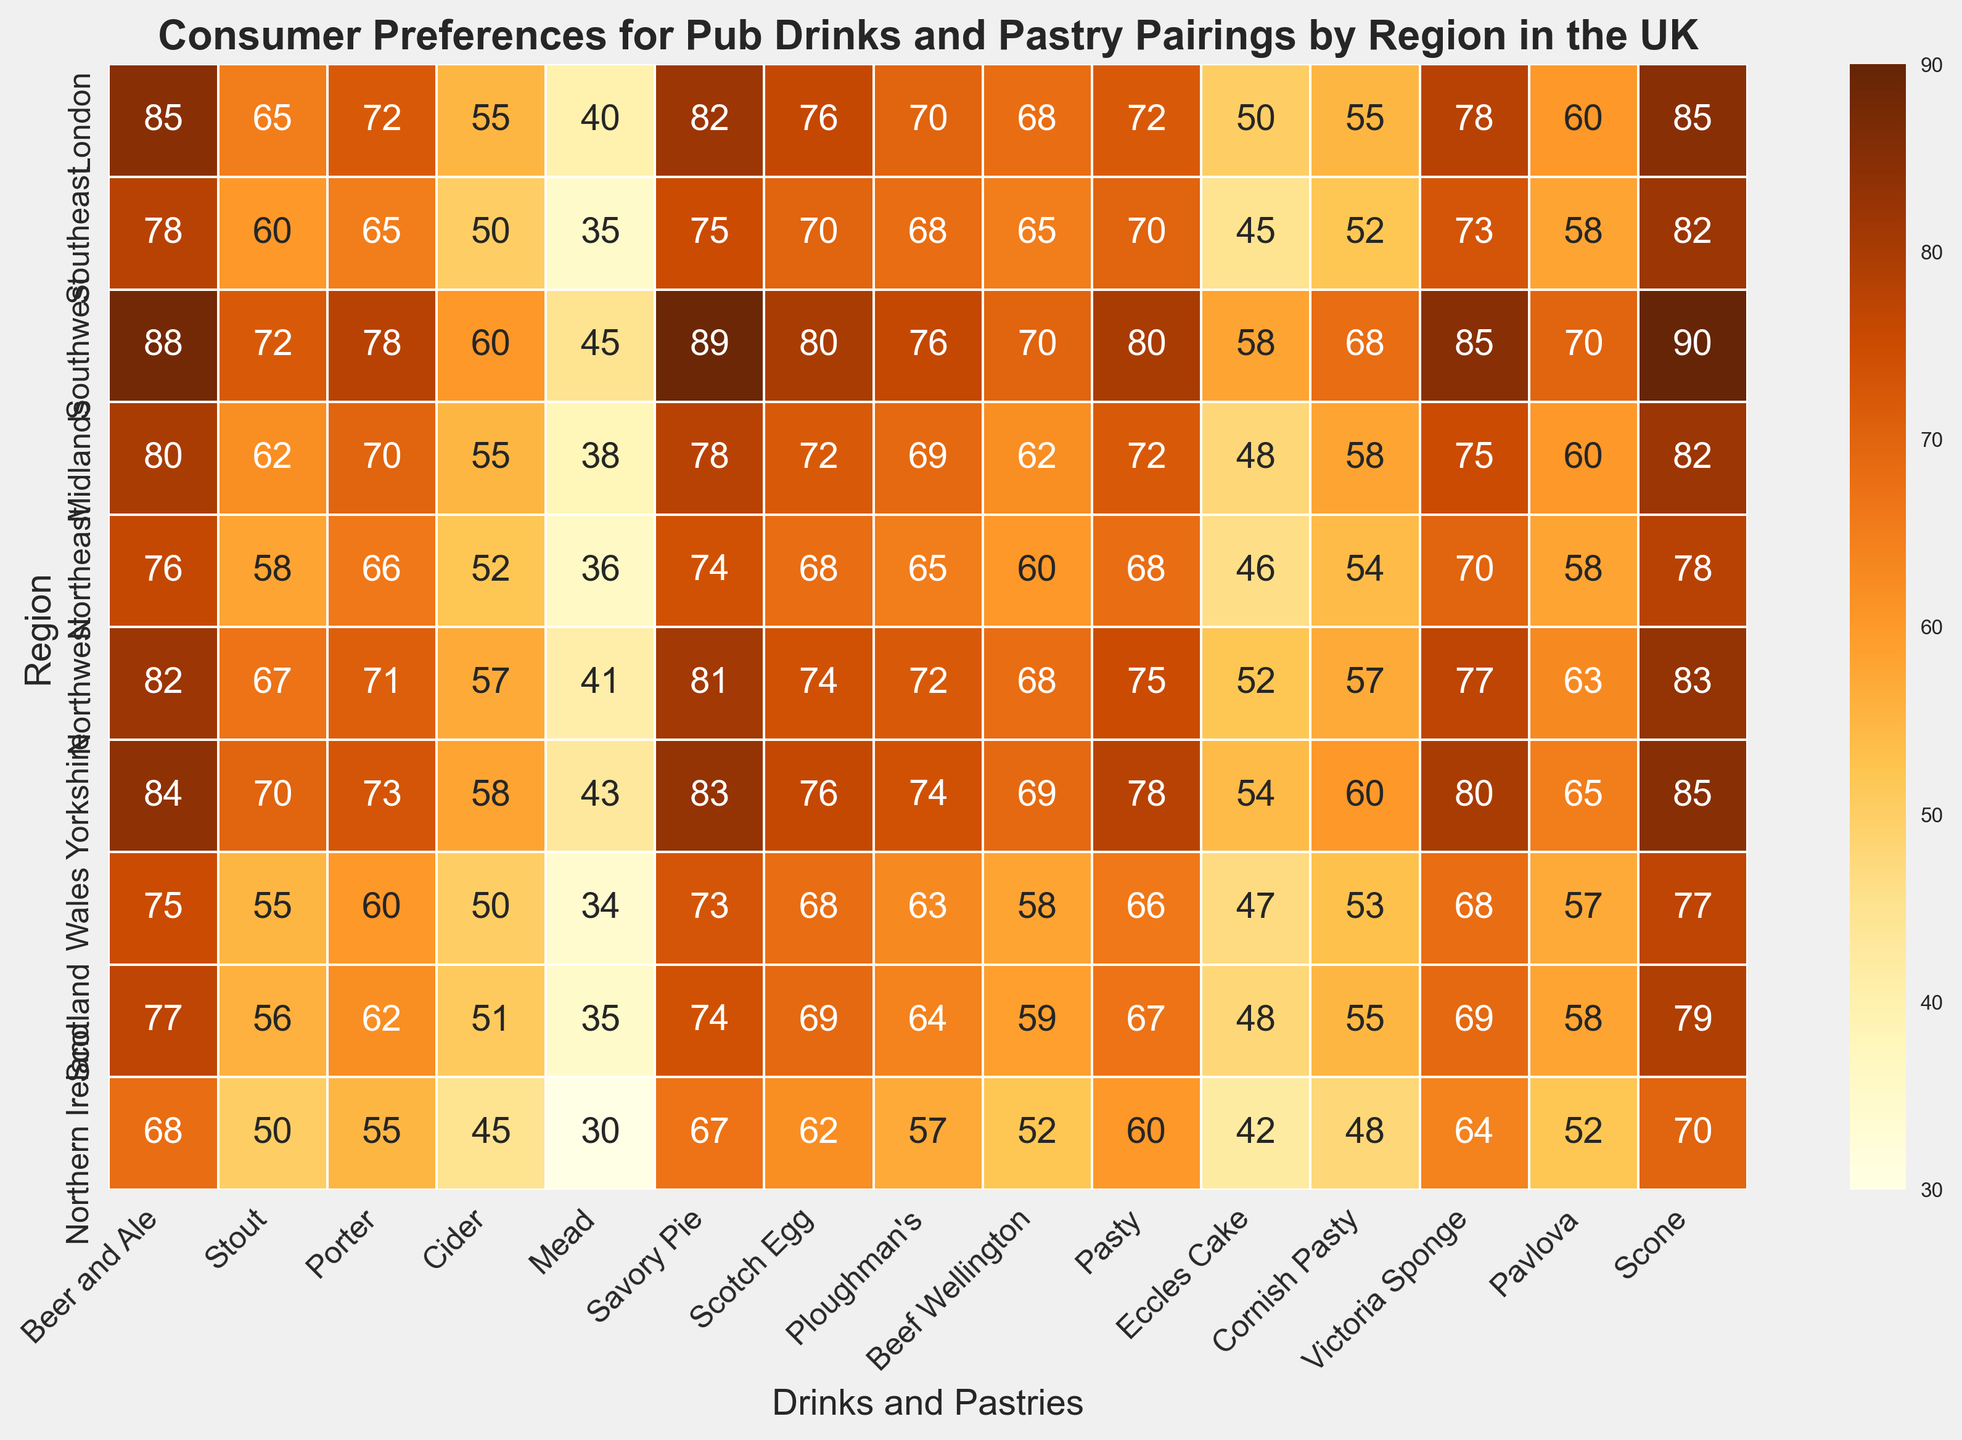Which region has the highest preference for Savory Pie? By observing the darkest cell in the Savory Pie column, we find that the Southwest region values Savory Pie the highest with a preference score of 89.
Answer: Southwest How does the preference for Beef Wellington in the Midlands compare to that in Northern Ireland? Check the value for Beef Wellington in the Midlands (62) and compare it with Northern Ireland (52). The Midlands prefer it more.
Answer: Midlands Which region values Mead the least, and what is the score? Look for the lightest cell in the Mead column, which is Northern Ireland with a score of 30.
Answer: Northern Ireland, 30 What is the average preference score for Beer and Ale across all regions? Sum the Beer and Ale scores (85 + 78 + 88 + 80 + 76 + 82 + 84 + 75 + 77 + 68) = 793, then divide by the number of regions (10). The average is 793/10 = 79.3.
Answer: 79.3 Which has a higher preference in London, Scones or Cornish Pasties? Compare the scores for Scones (85) and Cornish Pasties (55) in London. Scones have a higher preference.
Answer: Scones Is the preference for Porters generally higher in Northern or Southern UK regions? Sum the Porter scores for Northern (Northeast=66, Northwest=71, Yorkshire=73, Scotland=62, Northern Ireland=55) and Southern (London=72, Southeast=65, Southwest=78, Midlands=70, Wales=60). Northern summed score is 327, Southern is 345. Therefore, the preference is slightly higher in the Southern regions.
Answer: Southern What is the median preference score for Cider? Arrange the Cider scores in ascending order (30, 34, 35, 35, 36, 38, 40, 41, 43, 45, 45, 46, 50, 50, 51, 52, 55, 55, 57, 58, 60) and find the middle value. The median is 45.
Answer: 45 Which pastry has the highest preference in Wales and what is its score? Check the Wales row and look for the highest value, which is Savory Pie with a score of 73.
Answer: Savory Pie, 73 Compare the preferences for Victoria Sponge and Pavlova in Yorkshire. Look at the values for Victoria Sponge (80) and Pavlova (65) in Yorkshire and compare them. Victoria Sponge has a higher preference.
Answer: Victoria Sponge Is there any region where the preference for Scones is higher than 85? Check the Scones column to find any cell with a value higher than 85. There are no such cells; the highest score is 85 in London and Yorkshire.
Answer: No 